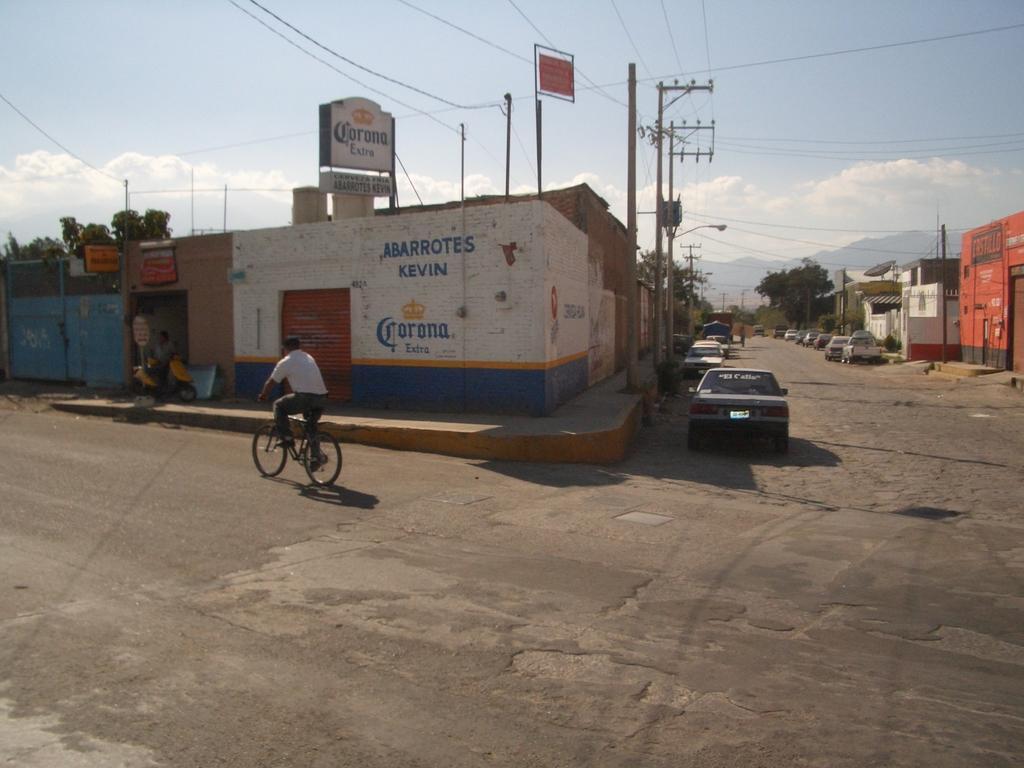In one or two sentences, can you explain what this image depicts? In this picture, we can see a few houses, and we can see a house with some text on it, and we can see a few vehicles, a person on bicycle, we can see the road, poles, posters, lights, mountains, trees and the sky with clouds. 